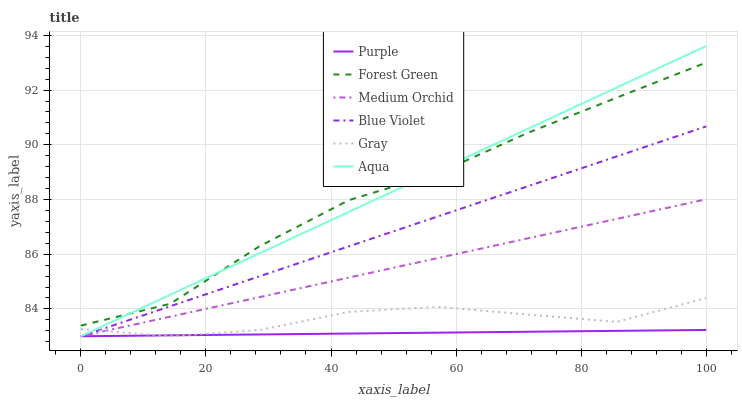Does Purple have the minimum area under the curve?
Answer yes or no. Yes. Does Aqua have the maximum area under the curve?
Answer yes or no. Yes. Does Medium Orchid have the minimum area under the curve?
Answer yes or no. No. Does Medium Orchid have the maximum area under the curve?
Answer yes or no. No. Is Blue Violet the smoothest?
Answer yes or no. Yes. Is Forest Green the roughest?
Answer yes or no. Yes. Is Purple the smoothest?
Answer yes or no. No. Is Purple the roughest?
Answer yes or no. No. Does Gray have the lowest value?
Answer yes or no. Yes. Does Forest Green have the lowest value?
Answer yes or no. No. Does Aqua have the highest value?
Answer yes or no. Yes. Does Medium Orchid have the highest value?
Answer yes or no. No. Is Medium Orchid less than Forest Green?
Answer yes or no. Yes. Is Forest Green greater than Blue Violet?
Answer yes or no. Yes. Does Blue Violet intersect Aqua?
Answer yes or no. Yes. Is Blue Violet less than Aqua?
Answer yes or no. No. Is Blue Violet greater than Aqua?
Answer yes or no. No. Does Medium Orchid intersect Forest Green?
Answer yes or no. No. 